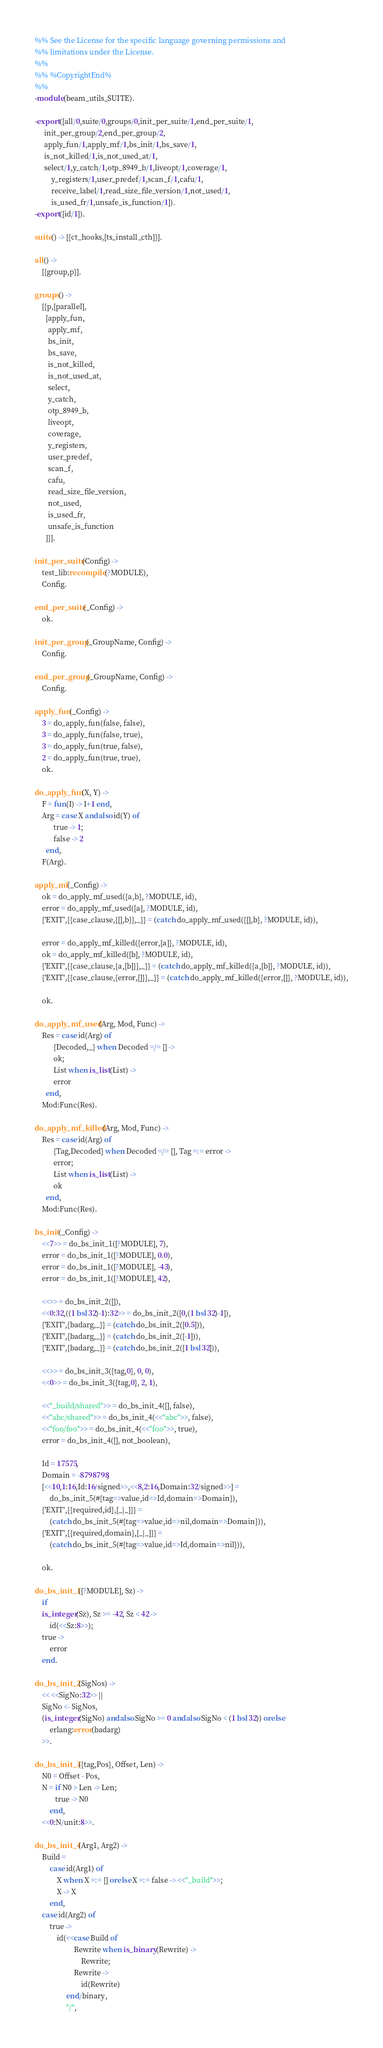<code> <loc_0><loc_0><loc_500><loc_500><_Erlang_>%% See the License for the specific language governing permissions and
%% limitations under the License.
%%
%% %CopyrightEnd%
%%
-module(beam_utils_SUITE).

-export([all/0,suite/0,groups/0,init_per_suite/1,end_per_suite/1,
	 init_per_group/2,end_per_group/2,
	 apply_fun/1,apply_mf/1,bs_init/1,bs_save/1,
	 is_not_killed/1,is_not_used_at/1,
	 select/1,y_catch/1,otp_8949_b/1,liveopt/1,coverage/1,
         y_registers/1,user_predef/1,scan_f/1,cafu/1,
         receive_label/1,read_size_file_version/1,not_used/1,
         is_used_fr/1,unsafe_is_function/1]).
-export([id/1]).

suite() -> [{ct_hooks,[ts_install_cth]}].

all() ->
    [{group,p}].

groups() ->
    [{p,[parallel],
      [apply_fun,
       apply_mf,
       bs_init,
       bs_save,
       is_not_killed,
       is_not_used_at,
       select,
       y_catch,
       otp_8949_b,
       liveopt,
       coverage,
       y_registers,
       user_predef,
       scan_f,
       cafu,
       read_size_file_version,
       not_used,
       is_used_fr,
       unsafe_is_function
      ]}].

init_per_suite(Config) ->
    test_lib:recompile(?MODULE),
    Config.

end_per_suite(_Config) ->
    ok.

init_per_group(_GroupName, Config) ->
    Config.

end_per_group(_GroupName, Config) ->
    Config.

apply_fun(_Config) ->
    3 = do_apply_fun(false, false),
    3 = do_apply_fun(false, true),
    3 = do_apply_fun(true, false),
    2 = do_apply_fun(true, true),
    ok.

do_apply_fun(X, Y) ->
    F = fun(I) -> I+1 end,
    Arg = case X andalso id(Y) of
	      true -> 1;
	      false -> 2
	  end,
    F(Arg).

apply_mf(_Config) ->
    ok = do_apply_mf_used({a,b}, ?MODULE, id),
    error = do_apply_mf_used([a], ?MODULE, id),
    {'EXIT',{{case_clause,{[],b}},_}} = (catch do_apply_mf_used({[],b}, ?MODULE, id)),

    error = do_apply_mf_killed({error,[a]}, ?MODULE, id),
    ok = do_apply_mf_killed([b], ?MODULE, id),
    {'EXIT',{{case_clause,{a,[b]}},_}} = (catch do_apply_mf_killed({a,[b]}, ?MODULE, id)),
    {'EXIT',{{case_clause,{error,[]}},_}} = (catch do_apply_mf_killed({error,[]}, ?MODULE, id)),

    ok.

do_apply_mf_used(Arg, Mod, Func) ->
    Res = case id(Arg) of
	      {Decoded,_} when Decoded =/= [] ->
		  ok;
	      List when is_list(List) ->
		  error
	  end,
    Mod:Func(Res).

do_apply_mf_killed(Arg, Mod, Func) ->
    Res = case id(Arg) of
	      {Tag,Decoded} when Decoded =/= [], Tag =:= error ->
		  error;
	      List when is_list(List) ->
		  ok
	  end,
    Mod:Func(Res).

bs_init(_Config) ->
    <<7>> = do_bs_init_1([?MODULE], 7),
    error = do_bs_init_1([?MODULE], 0.0),
    error = do_bs_init_1([?MODULE], -43),
    error = do_bs_init_1([?MODULE], 42),

    <<>> = do_bs_init_2([]),
    <<0:32,((1 bsl 32)-1):32>> = do_bs_init_2([0,(1 bsl 32)-1]),
    {'EXIT',{badarg,_}} = (catch do_bs_init_2([0.5])),
    {'EXIT',{badarg,_}} = (catch do_bs_init_2([-1])),
    {'EXIT',{badarg,_}} = (catch do_bs_init_2([1 bsl 32])),

    <<>> = do_bs_init_3({tag,0}, 0, 0),
    <<0>> = do_bs_init_3({tag,0}, 2, 1),

    <<"_build/shared">> = do_bs_init_4([], false),
    <<"abc/shared">> = do_bs_init_4(<<"abc">>, false),
    <<"foo/foo">> = do_bs_init_4(<<"foo">>, true),
    error = do_bs_init_4([], not_boolean),

    Id = 17575,
    Domain = -8798798,
    [<<10,1:16,Id:16/signed>>,<<8,2:16,Domain:32/signed>>] =
        do_bs_init_5(#{tag=>value,id=>Id,domain=>Domain}),
    {'EXIT',{{required,id},[_|_]}} =
        (catch do_bs_init_5(#{tag=>value,id=>nil,domain=>Domain})),
    {'EXIT',{{required,domain},[_|_]}} =
        (catch do_bs_init_5(#{tag=>value,id=>Id,domain=>nil})),

    ok.

do_bs_init_1([?MODULE], Sz) ->
    if
	is_integer(Sz), Sz >= -42, Sz < 42 ->
	    id(<<Sz:8>>);
	true ->
	    error
    end.

do_bs_init_2(SigNos) ->
    << <<SigNo:32>> ||
	SigNo <- SigNos,
	(is_integer(SigNo) andalso SigNo >= 0 andalso SigNo < (1 bsl 32)) orelse
	    erlang:error(badarg)
    >>.

do_bs_init_3({tag,Pos}, Offset, Len) ->
    N0 = Offset - Pos,
    N = if N0 > Len -> Len;
           true -> N0
        end,
    <<0:N/unit:8>>.

do_bs_init_4(Arg1, Arg2) ->
    Build =
        case id(Arg1) of
            X when X =:= [] orelse X =:= false -> <<"_build">>;
            X -> X
        end,
    case id(Arg2) of
        true ->
            id(<<case Build of
                     Rewrite when is_binary(Rewrite) ->
                         Rewrite;
                     Rewrite ->
                         id(Rewrite)
                 end/binary,
                 "/",</code> 